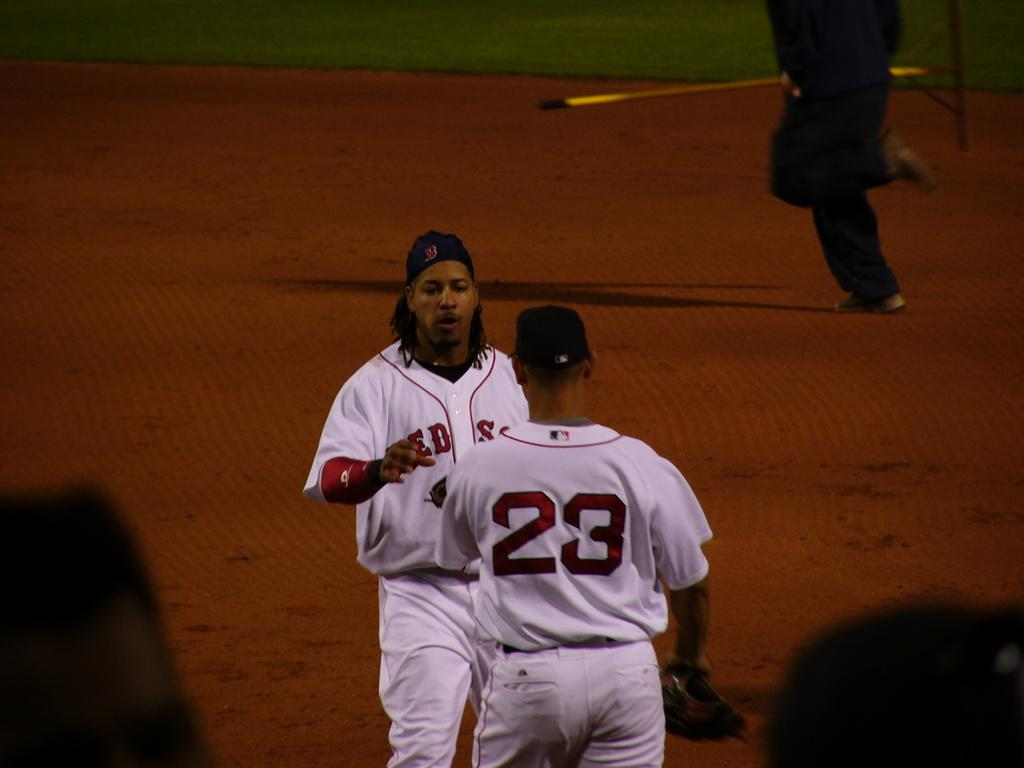Provide a one-sentence caption for the provided image. two baseball players in white jerseys and one with 23 on the back. 